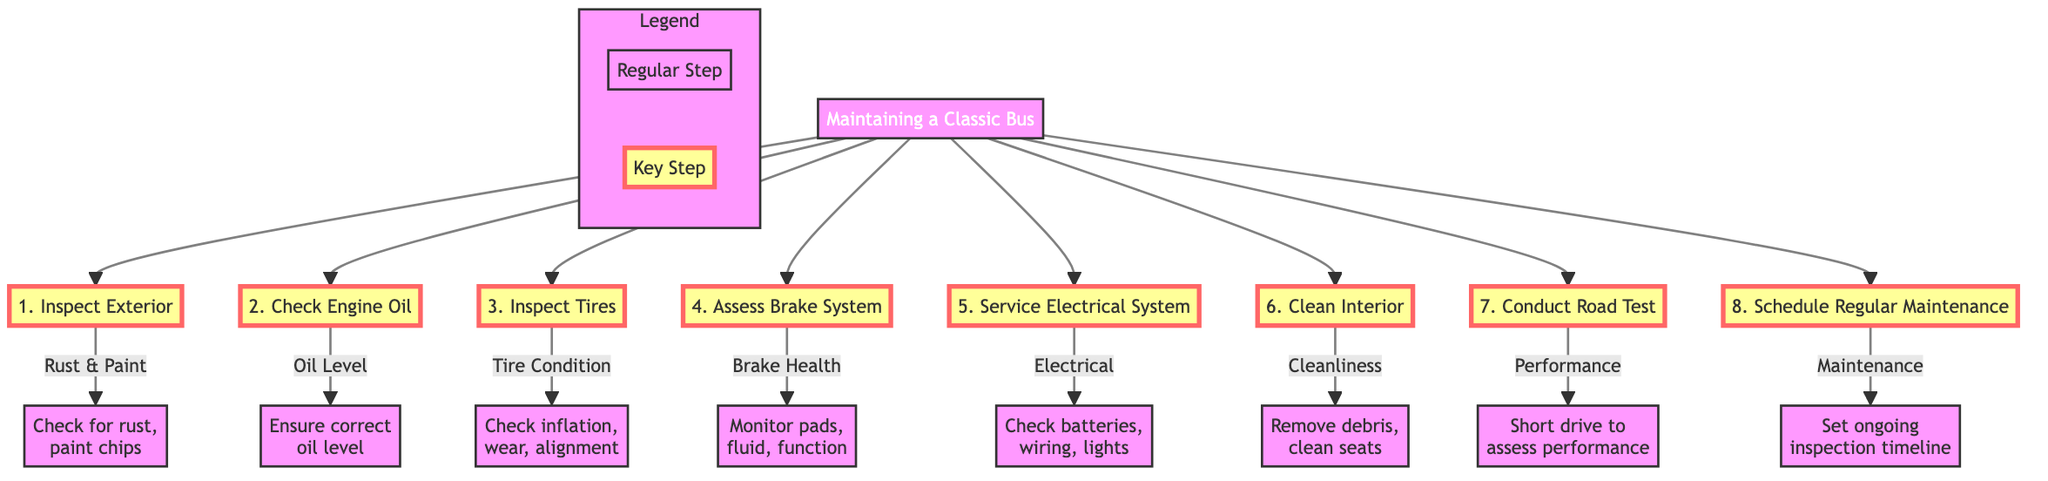What's the first step in maintaining a classic bus? The first step listed in the diagram is "Inspect Exterior". This is directly visible as the first node flowing from the main topic “Maintaining a Classic Bus”.
Answer: Inspect Exterior How many total steps are listed in the maintenance process? Counting all the steps from the node that flows out of the main topic, there are eight distinct steps.
Answer: 8 Which step involves checking the brake system? In the diagram, the step that involves assessing the brake system is labeled as "Assess Brake System". It is the fourth step in the flowchart.
Answer: Assess Brake System What is the purpose of the last step in the maintenance flowchart? The last step, "Schedule Regular Maintenance", is intended to set up a timeline for ongoing inspections and repairs. This is indicated in the description of the last node in the flowchart.
Answer: Set up a timeline Which steps require checking or monitoring? The steps that require checking or monitoring are: "Inspect Exterior", "Check Engine Oil", "Inspect Tires", "Assess Brake System", and "Service Electrical System". Each of these steps includes a directive to check or monitor various conditions.
Answer: Inspect Exterior, Check Engine Oil, Inspect Tires, Assess Brake System, Service Electrical System What does the first sub-step of "Inspect Exterior" describe? The first sub-step under "Inspect Exterior" describes checking for rust and paint chips. It is detailed as "Check for rust, paint chips" which follows from the main step.
Answer: Check for rust, paint chips How do the steps flow from the main title? The steps flow from the main title in a vertical manner, with each step connected sequentially below "Maintaining a Classic Bus", illustrating a clear order of operations for the maintenance process.
Answer: Vertically downwards Which step involves a practical test of the bus? The step that involves a practical test of the bus is "Conduct Road Test", which follows after cleaning the interior and assessing the various systems. This is explicitly stated in the description.
Answer: Conduct Road Test 